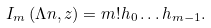<formula> <loc_0><loc_0><loc_500><loc_500>I _ { m } \left ( \Lambda n , z \right ) = m ! h _ { 0 } \dots h _ { m - 1 } .</formula> 